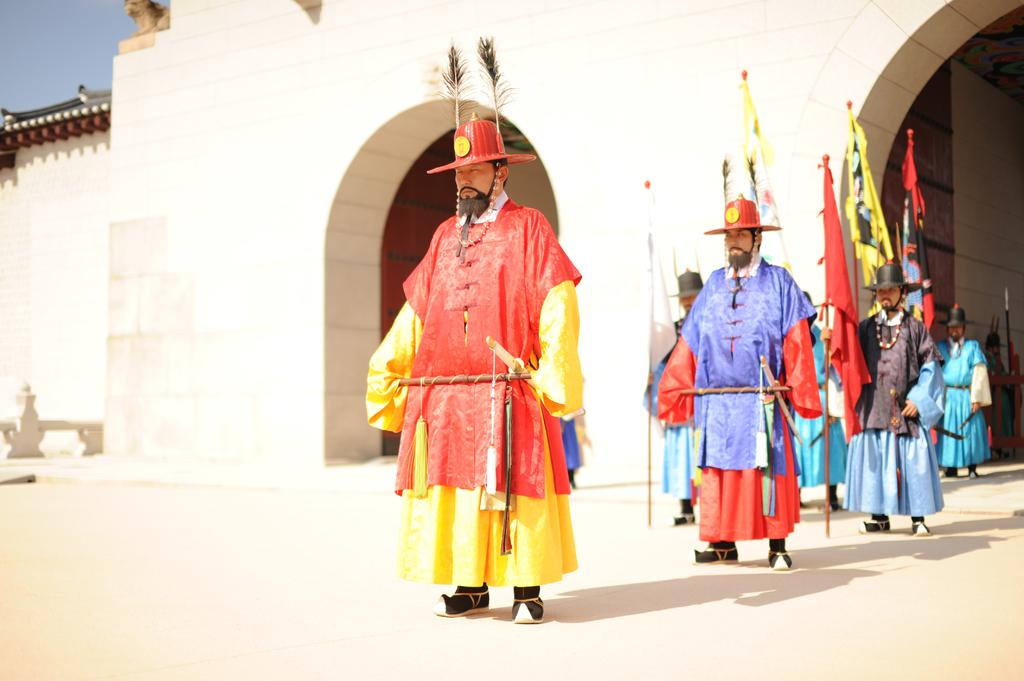What are the people in the image doing? The people in the image are standing. What accessories are some of the people wearing? Some of the people are wearing hats. What objects are some of the people holding? Some of the people are holding flags and spears. What structure can be seen in the image? There is a building visible in the image. What type of vegetable is being used as a bag by one of the people in the image? There is no vegetable being used as a bag in the image; the people are holding flags and spears, but no bags or vegetables are present. 